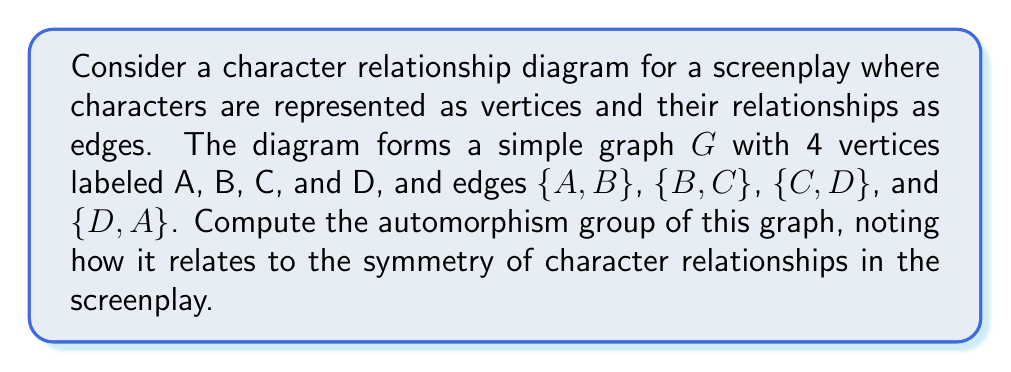What is the answer to this math problem? To compute the automorphism group of the given character relationship diagram, we'll follow these steps:

1) First, let's visualize the graph:

[asy]
unitsize(1cm);
pair A = (0,0), B = (2,0), C = (2,2), D = (0,2);
draw(A--B--C--D--A);
dot(A); dot(B); dot(C); dot(D);
label("A", A, SW);
label("B", B, SE);
label("C", C, NE);
label("D", D, NW);
[/asy]

2) An automorphism of this graph is a permutation of the vertices that preserves adjacency. In other words, it's a way to relabel the vertices while keeping the structure of the graph intact.

3) We can see that this graph is actually a cycle of length 4, also known as $C_4$.

4) The automorphisms of $C_4$ are:
   - Identity: (A)(B)(C)(D)
   - Rotations: (ABCD), (ADCB)
   - Reflections: (AC)(BD), (AB)(CD), (AD)(BC)

5) These automorphisms form a group under composition. This group is isomorphic to the dihedral group $D_4$, which has order 8.

6) In terms of screenplay analysis, each automorphism represents a way to "retell" the story while preserving the structure of character relationships. For example, the rotation (ABCD) could represent telling the story from each character's perspective in turn.

7) The fact that this graph has non-trivial automorphisms suggests that the character relationships have a certain symmetry or balance, which could be an important aspect of the screenplay's structure.
Answer: The automorphism group of the given character relationship diagram is isomorphic to the dihedral group $D_4$, which has order 8. 